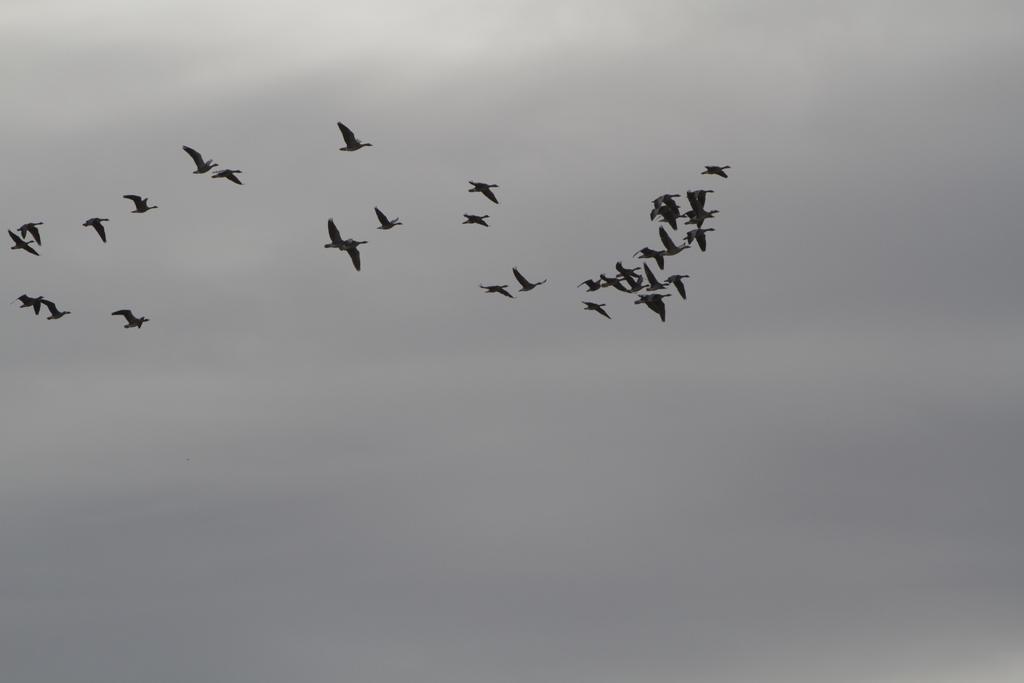In one or two sentences, can you explain what this image depicts? In this image I can see few black colored birds are flying in the air. On the top of the image I can see the sky. It is cloudy. 